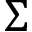<formula> <loc_0><loc_0><loc_500><loc_500>\Sigma</formula> 